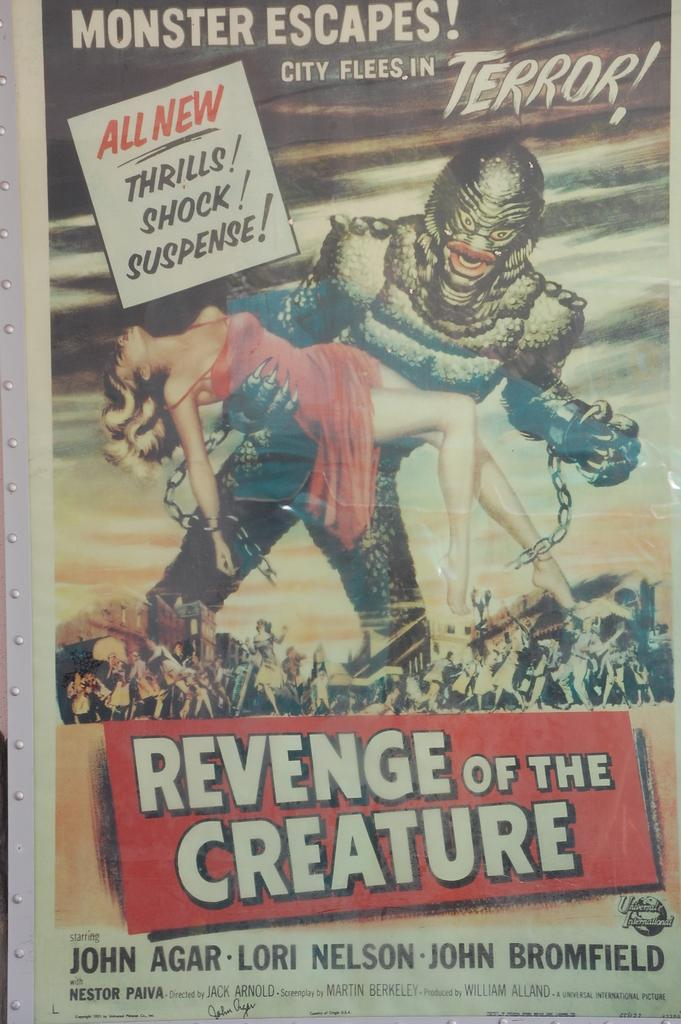<image>
Provide a brief description of the given image. A poster for the movie "Revenge of the Creature" featuring a woman being held by a monster in chains. 